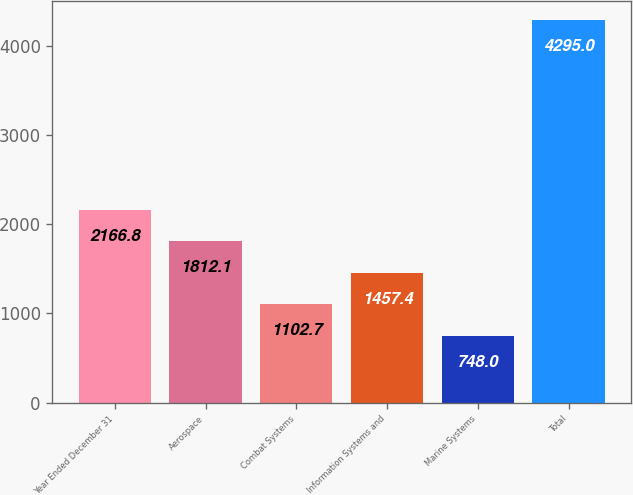<chart> <loc_0><loc_0><loc_500><loc_500><bar_chart><fcel>Year Ended December 31<fcel>Aerospace<fcel>Combat Systems<fcel>Information Systems and<fcel>Marine Systems<fcel>Total<nl><fcel>2166.8<fcel>1812.1<fcel>1102.7<fcel>1457.4<fcel>748<fcel>4295<nl></chart> 